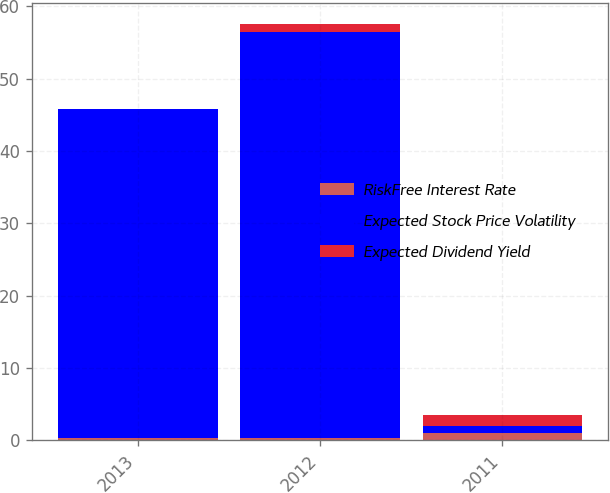Convert chart. <chart><loc_0><loc_0><loc_500><loc_500><stacked_bar_chart><ecel><fcel>2013<fcel>2012<fcel>2011<nl><fcel>RiskFree Interest Rate<fcel>0.4<fcel>0.4<fcel>1<nl><fcel>Expected Stock Price Volatility<fcel>45.4<fcel>56<fcel>1.05<nl><fcel>Expected Dividend Yield<fcel>0<fcel>1.1<fcel>1.5<nl></chart> 